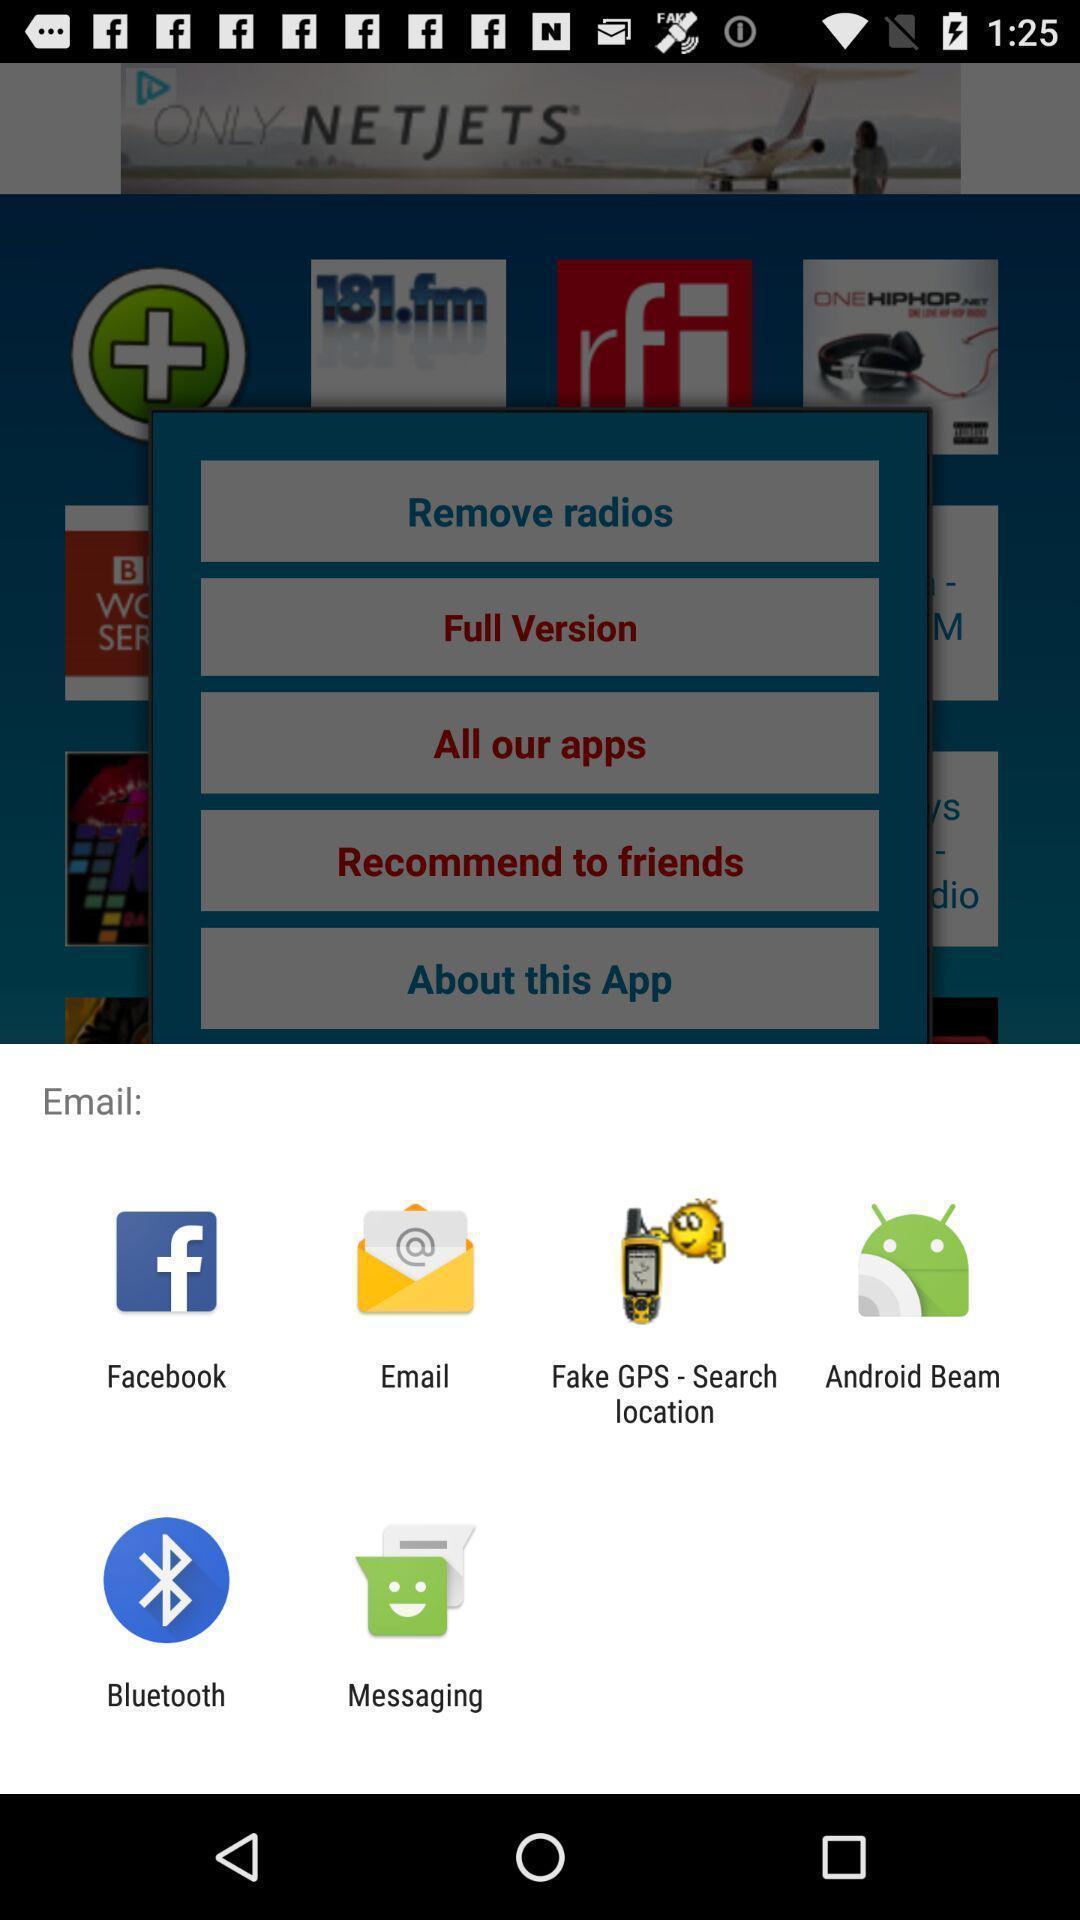Provide a textual representation of this image. Pop-up shows to email with multiple applications. 